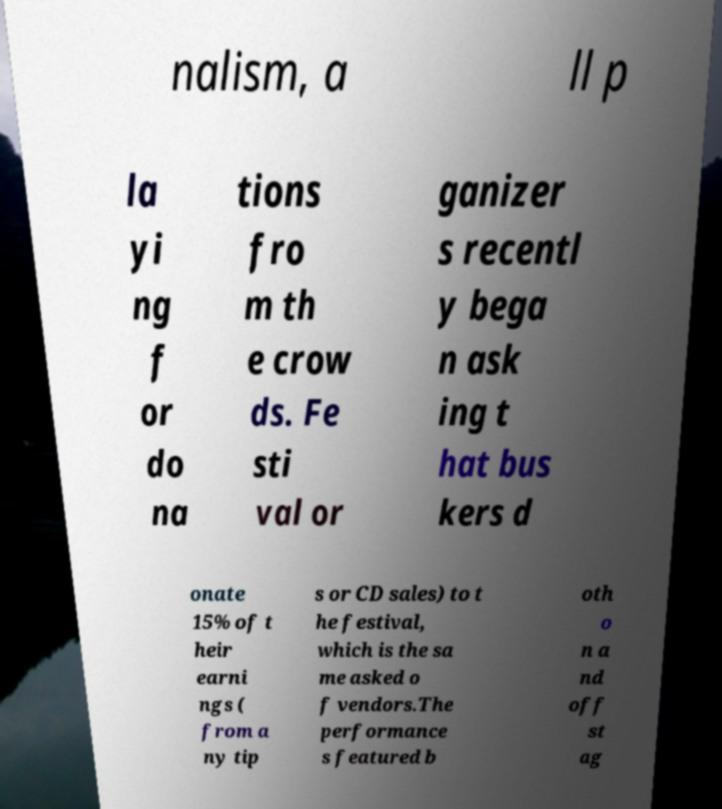For documentation purposes, I need the text within this image transcribed. Could you provide that? nalism, a ll p la yi ng f or do na tions fro m th e crow ds. Fe sti val or ganizer s recentl y bega n ask ing t hat bus kers d onate 15% of t heir earni ngs ( from a ny tip s or CD sales) to t he festival, which is the sa me asked o f vendors.The performance s featured b oth o n a nd off st ag 